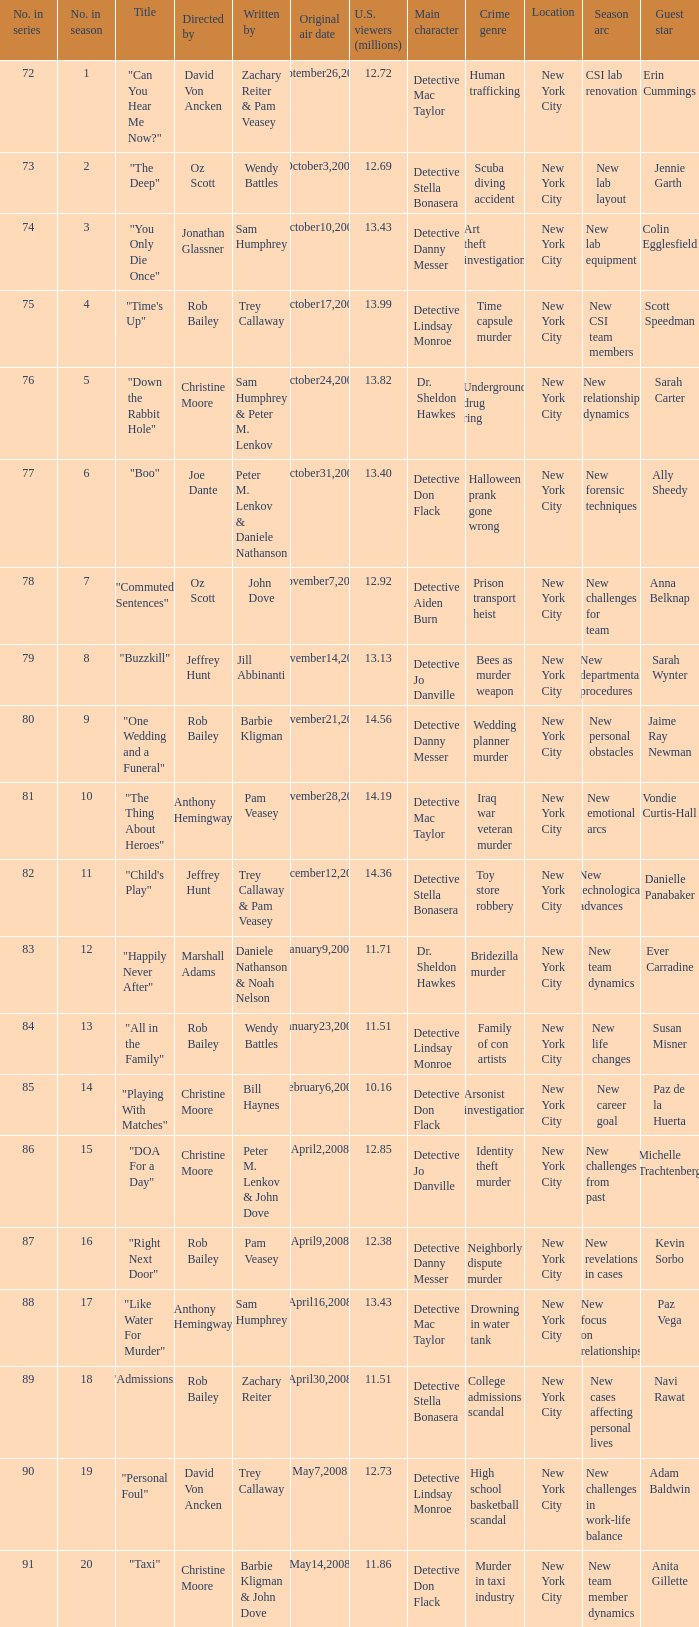How many millions of U.S. viewers watched the episode "Buzzkill"?  1.0. 